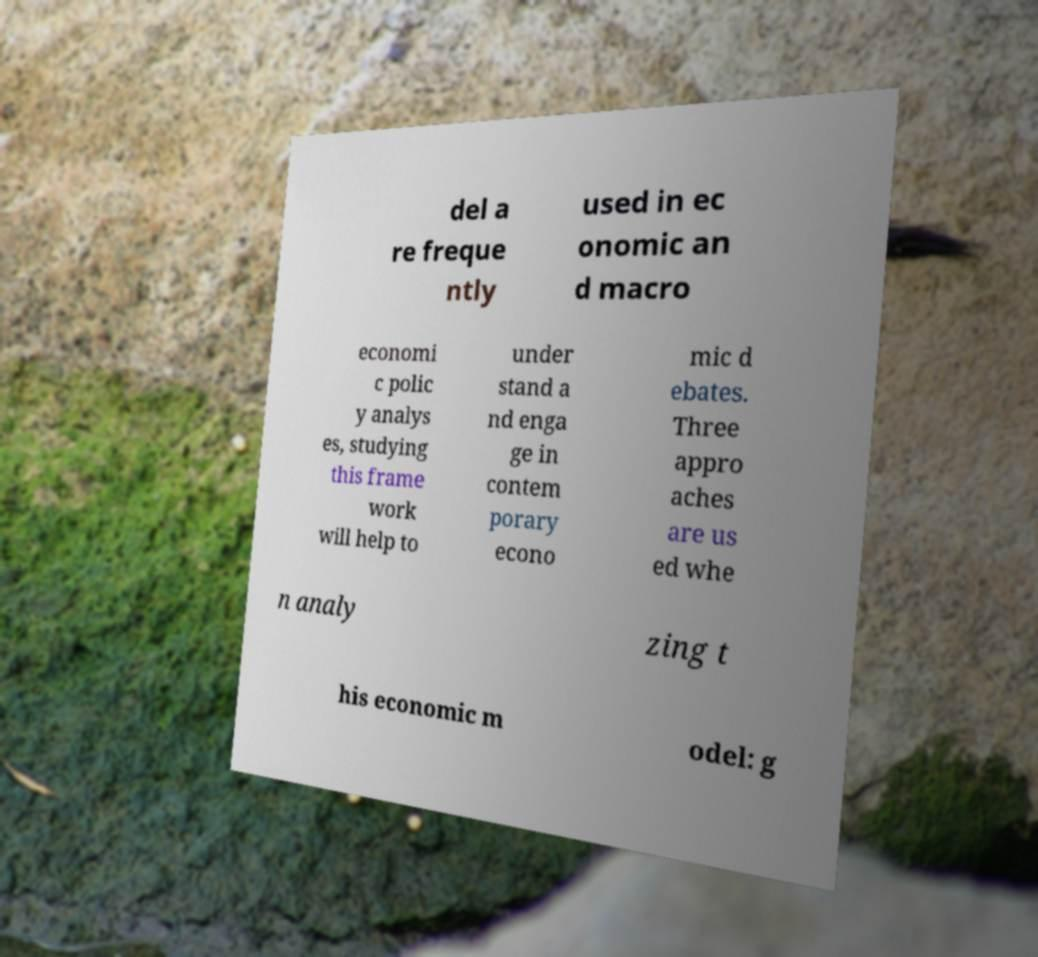Please read and relay the text visible in this image. What does it say? del a re freque ntly used in ec onomic an d macro economi c polic y analys es, studying this frame work will help to under stand a nd enga ge in contem porary econo mic d ebates. Three appro aches are us ed whe n analy zing t his economic m odel: g 